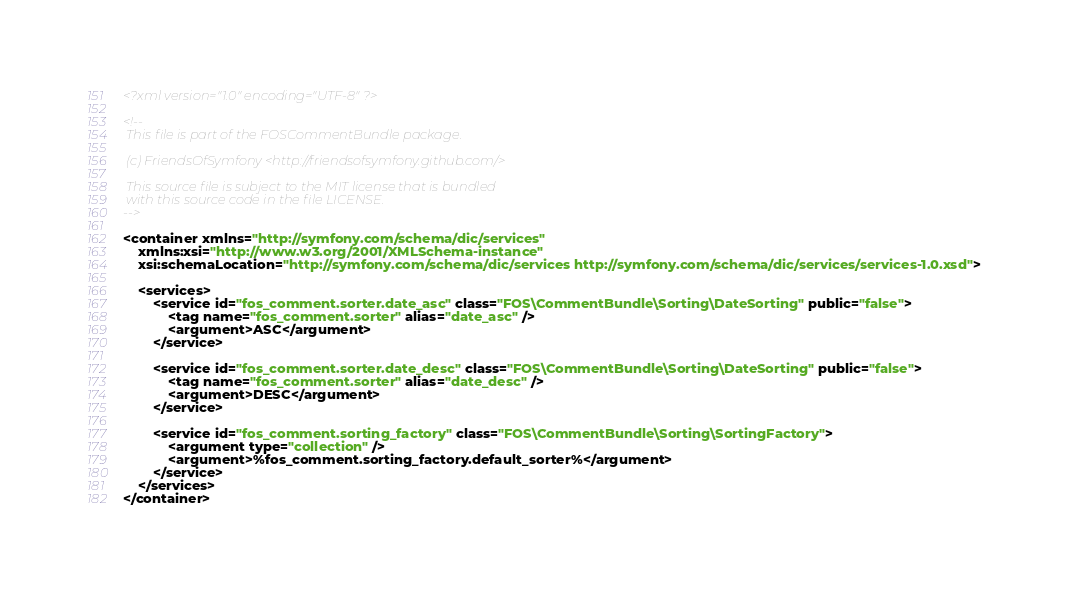Convert code to text. <code><loc_0><loc_0><loc_500><loc_500><_XML_><?xml version="1.0" encoding="UTF-8" ?>

<!--
 This file is part of the FOSCommentBundle package.

 (c) FriendsOfSymfony <http://friendsofsymfony.github.com/>

 This source file is subject to the MIT license that is bundled
 with this source code in the file LICENSE.
-->

<container xmlns="http://symfony.com/schema/dic/services"
    xmlns:xsi="http://www.w3.org/2001/XMLSchema-instance"
    xsi:schemaLocation="http://symfony.com/schema/dic/services http://symfony.com/schema/dic/services/services-1.0.xsd">

    <services>
        <service id="fos_comment.sorter.date_asc" class="FOS\CommentBundle\Sorting\DateSorting" public="false">
            <tag name="fos_comment.sorter" alias="date_asc" />
            <argument>ASC</argument>
        </service>

        <service id="fos_comment.sorter.date_desc" class="FOS\CommentBundle\Sorting\DateSorting" public="false">
            <tag name="fos_comment.sorter" alias="date_desc" />
            <argument>DESC</argument>
        </service>

        <service id="fos_comment.sorting_factory" class="FOS\CommentBundle\Sorting\SortingFactory">
            <argument type="collection" />
            <argument>%fos_comment.sorting_factory.default_sorter%</argument>
        </service>
    </services>
</container>
</code> 